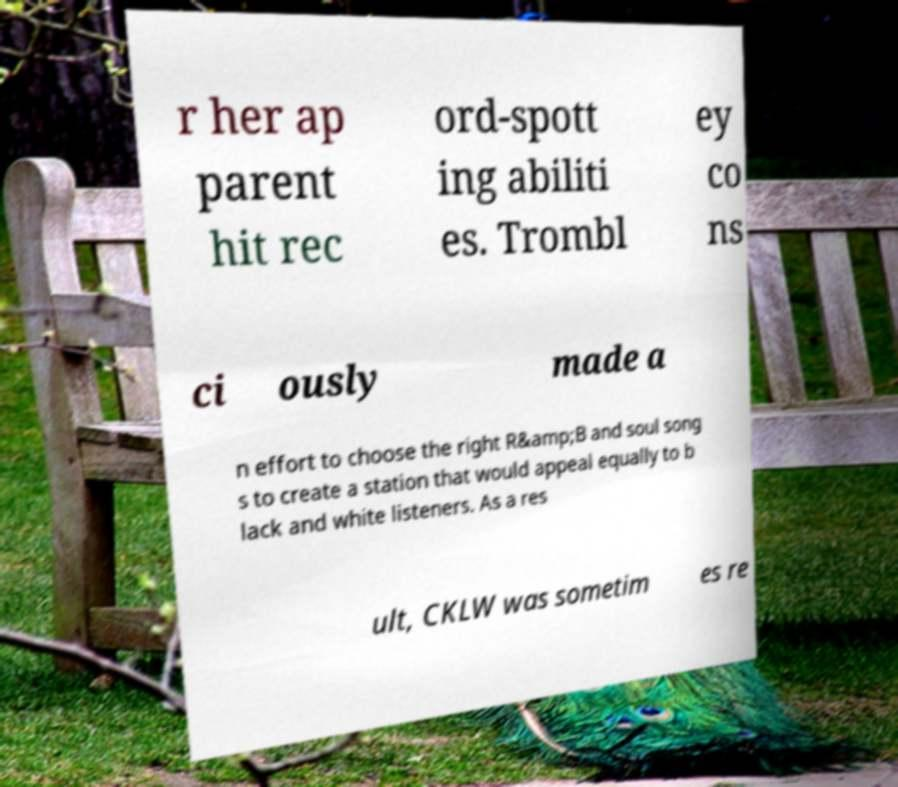Could you assist in decoding the text presented in this image and type it out clearly? r her ap parent hit rec ord-spott ing abiliti es. Trombl ey co ns ci ously made a n effort to choose the right R&amp;B and soul song s to create a station that would appeal equally to b lack and white listeners. As a res ult, CKLW was sometim es re 